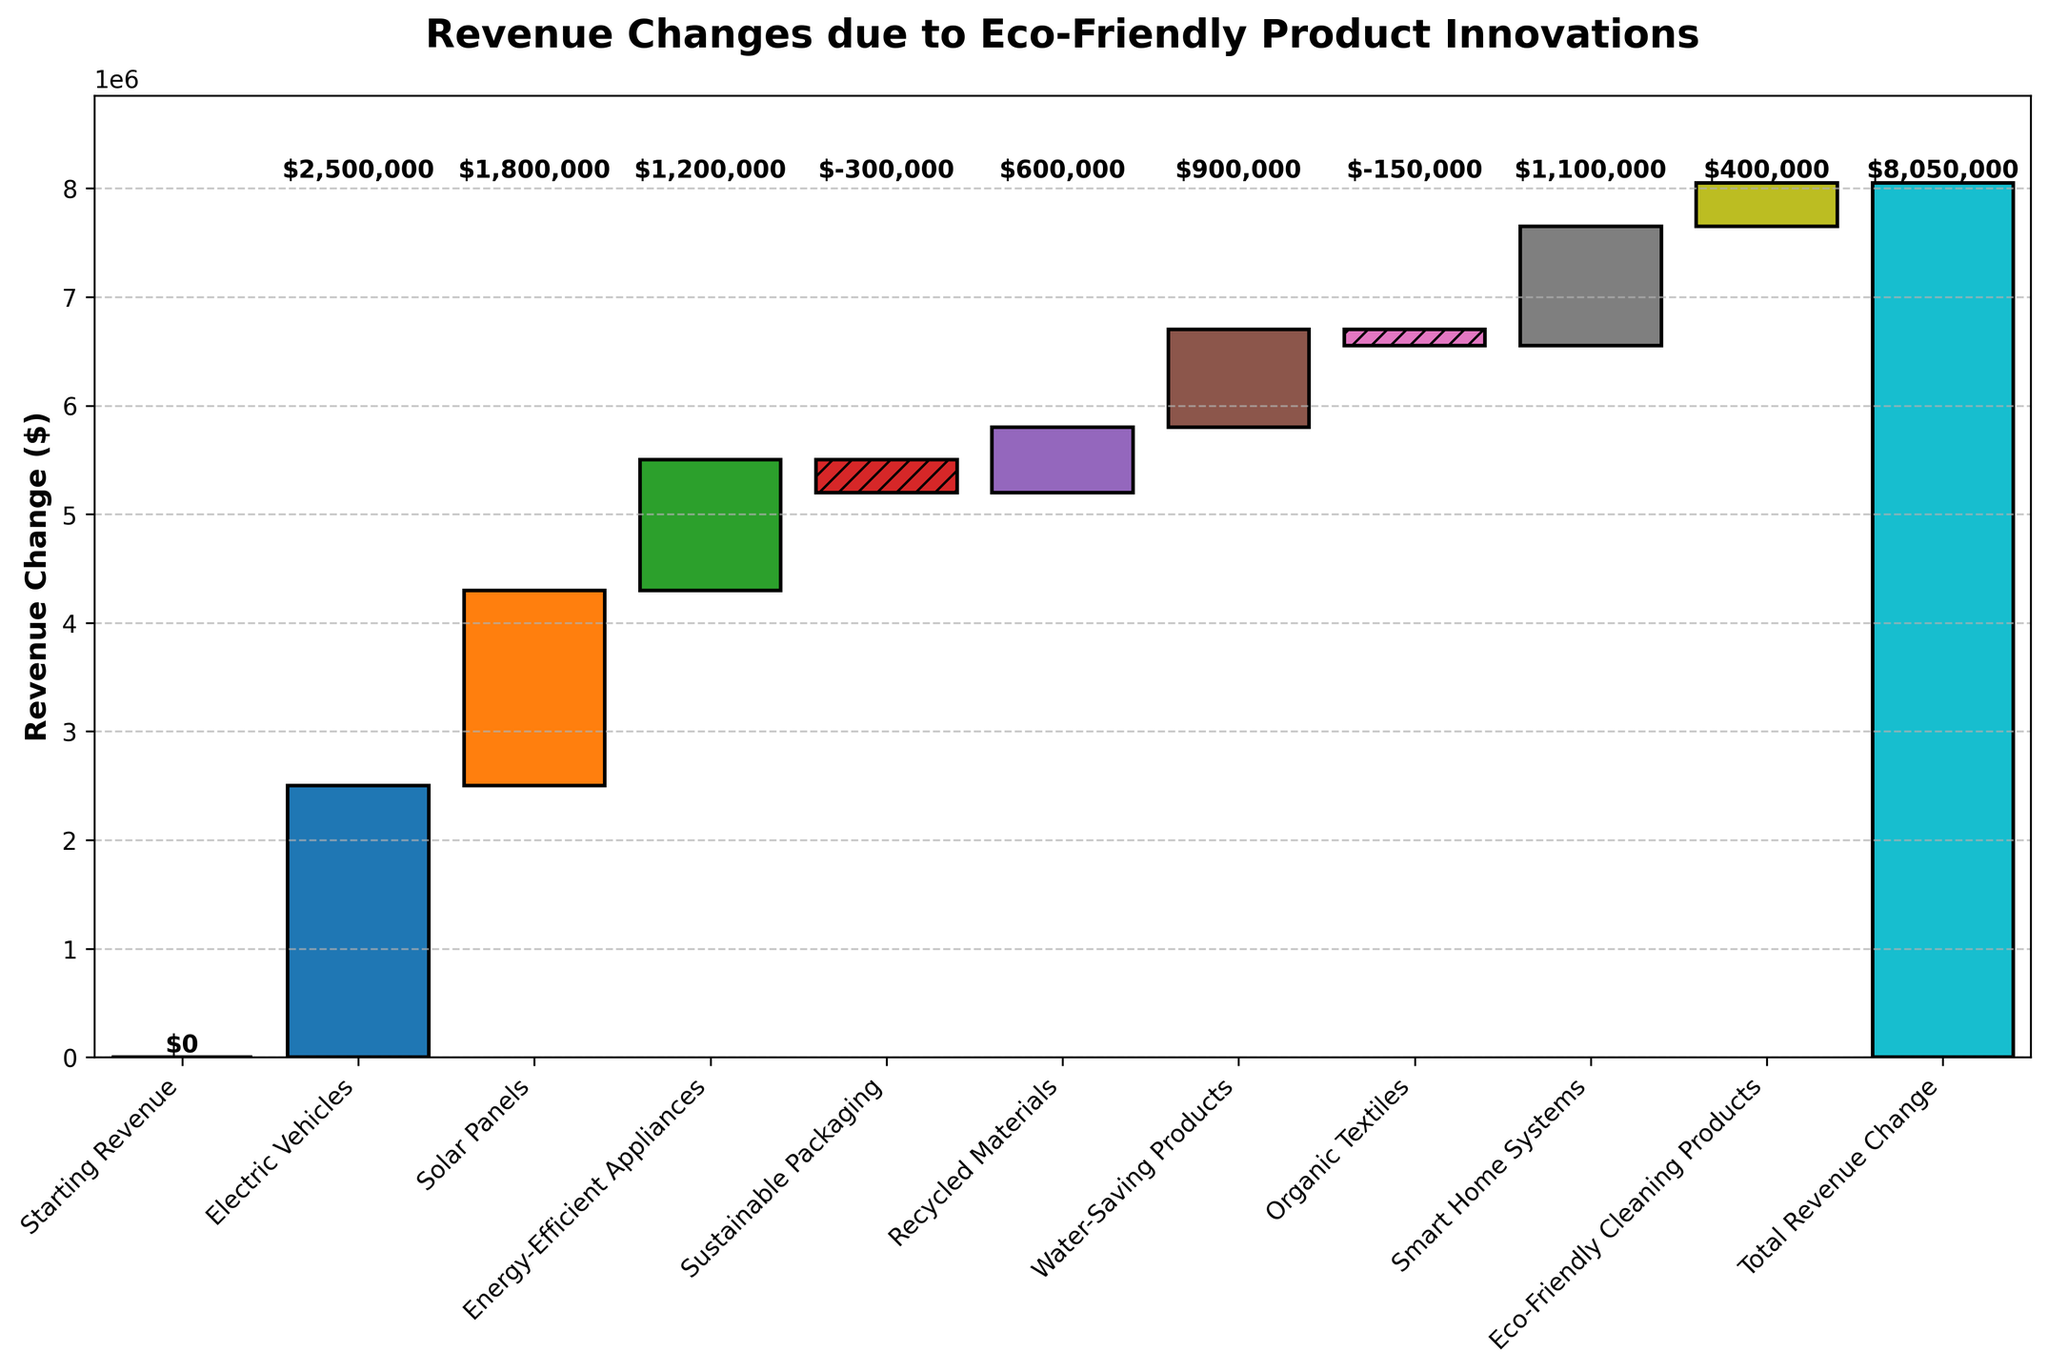What's the title of the figure? The title is usually displayed at the top of a figure. In this case, it reads "Revenue Changes due to Eco-Friendly Product Innovations".
Answer: Revenue Changes due to Eco-Friendly Product Innovations What is the starting revenue? The starting revenue is indicated by the first bar in the chart, which is the baseline from which all changes are measured. According to the data, the starting revenue is the first entry with a value of 0.
Answer: 0 Which product category has the highest positive revenue change? To find the highest positive revenue change, we need to look at the bar with the greatest height going upwards. According to the data, "Electric Vehicles" has the highest positive change with a value of +2,500,000.
Answer: Electric Vehicles What is the total revenue change? The total revenue change is displayed as the last bar in a waterfall chart, summarizing all the individual changes. According to the data, the total revenue change is 8,050,000.
Answer: 8,050,000 How much did "Energy-Efficient Appliances" contribute to the revenue change? To find the contribution of "Energy-Efficient Appliances", check the relevant bar's height in the chart. The data shows that "Energy-Efficient Appliances" contributed +1,200,000.
Answer: 1,200,000 How many categories show a decrease in revenue? We need to count the number of bars that go downward from the baseline. According to the data, only "Sustainable Packaging" and "Organic Textiles" show a decrease, with values of -300,000 and -150,000 respectively.
Answer: 2 What is the combined revenue change of "Solar Panels" and "Smart Home Systems"? Add the revenue changes for "Solar Panels" and "Smart Home Systems" together. According to the data, the changes are +1,800,000 and +1,100,000, respectively, summing up to +2,900,000.
Answer: 2,900,000 Which product category had the smallest positive revenue change? Among the positive changes, the smallest bar height represents the smallest change. The data indicates that "Eco-Friendly Cleaning Products" had the smallest positive change, which is +400,000.
Answer: Eco-Friendly Cleaning Products By how much did "Recycled Materials" change the revenue? Refer to the bar corresponding to "Recycled Materials" and note its value. The data shows that "Recycled Materials" contributed +600,000 to the revenue change.
Answer: 600,000 Are there more categories with positive revenue changes or negative ones? Count the categories with upward and downward bars. According to the data, there are 7 categories with positive changes and 2 with negative changes, hence more positive changes.
Answer: Positive changes 